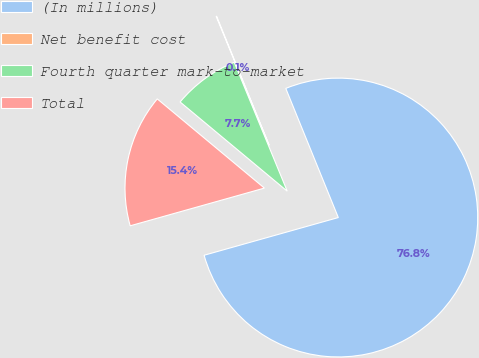Convert chart to OTSL. <chart><loc_0><loc_0><loc_500><loc_500><pie_chart><fcel>(In millions)<fcel>Net benefit cost<fcel>Fourth quarter mark-to-market<fcel>Total<nl><fcel>76.79%<fcel>0.06%<fcel>7.74%<fcel>15.41%<nl></chart> 